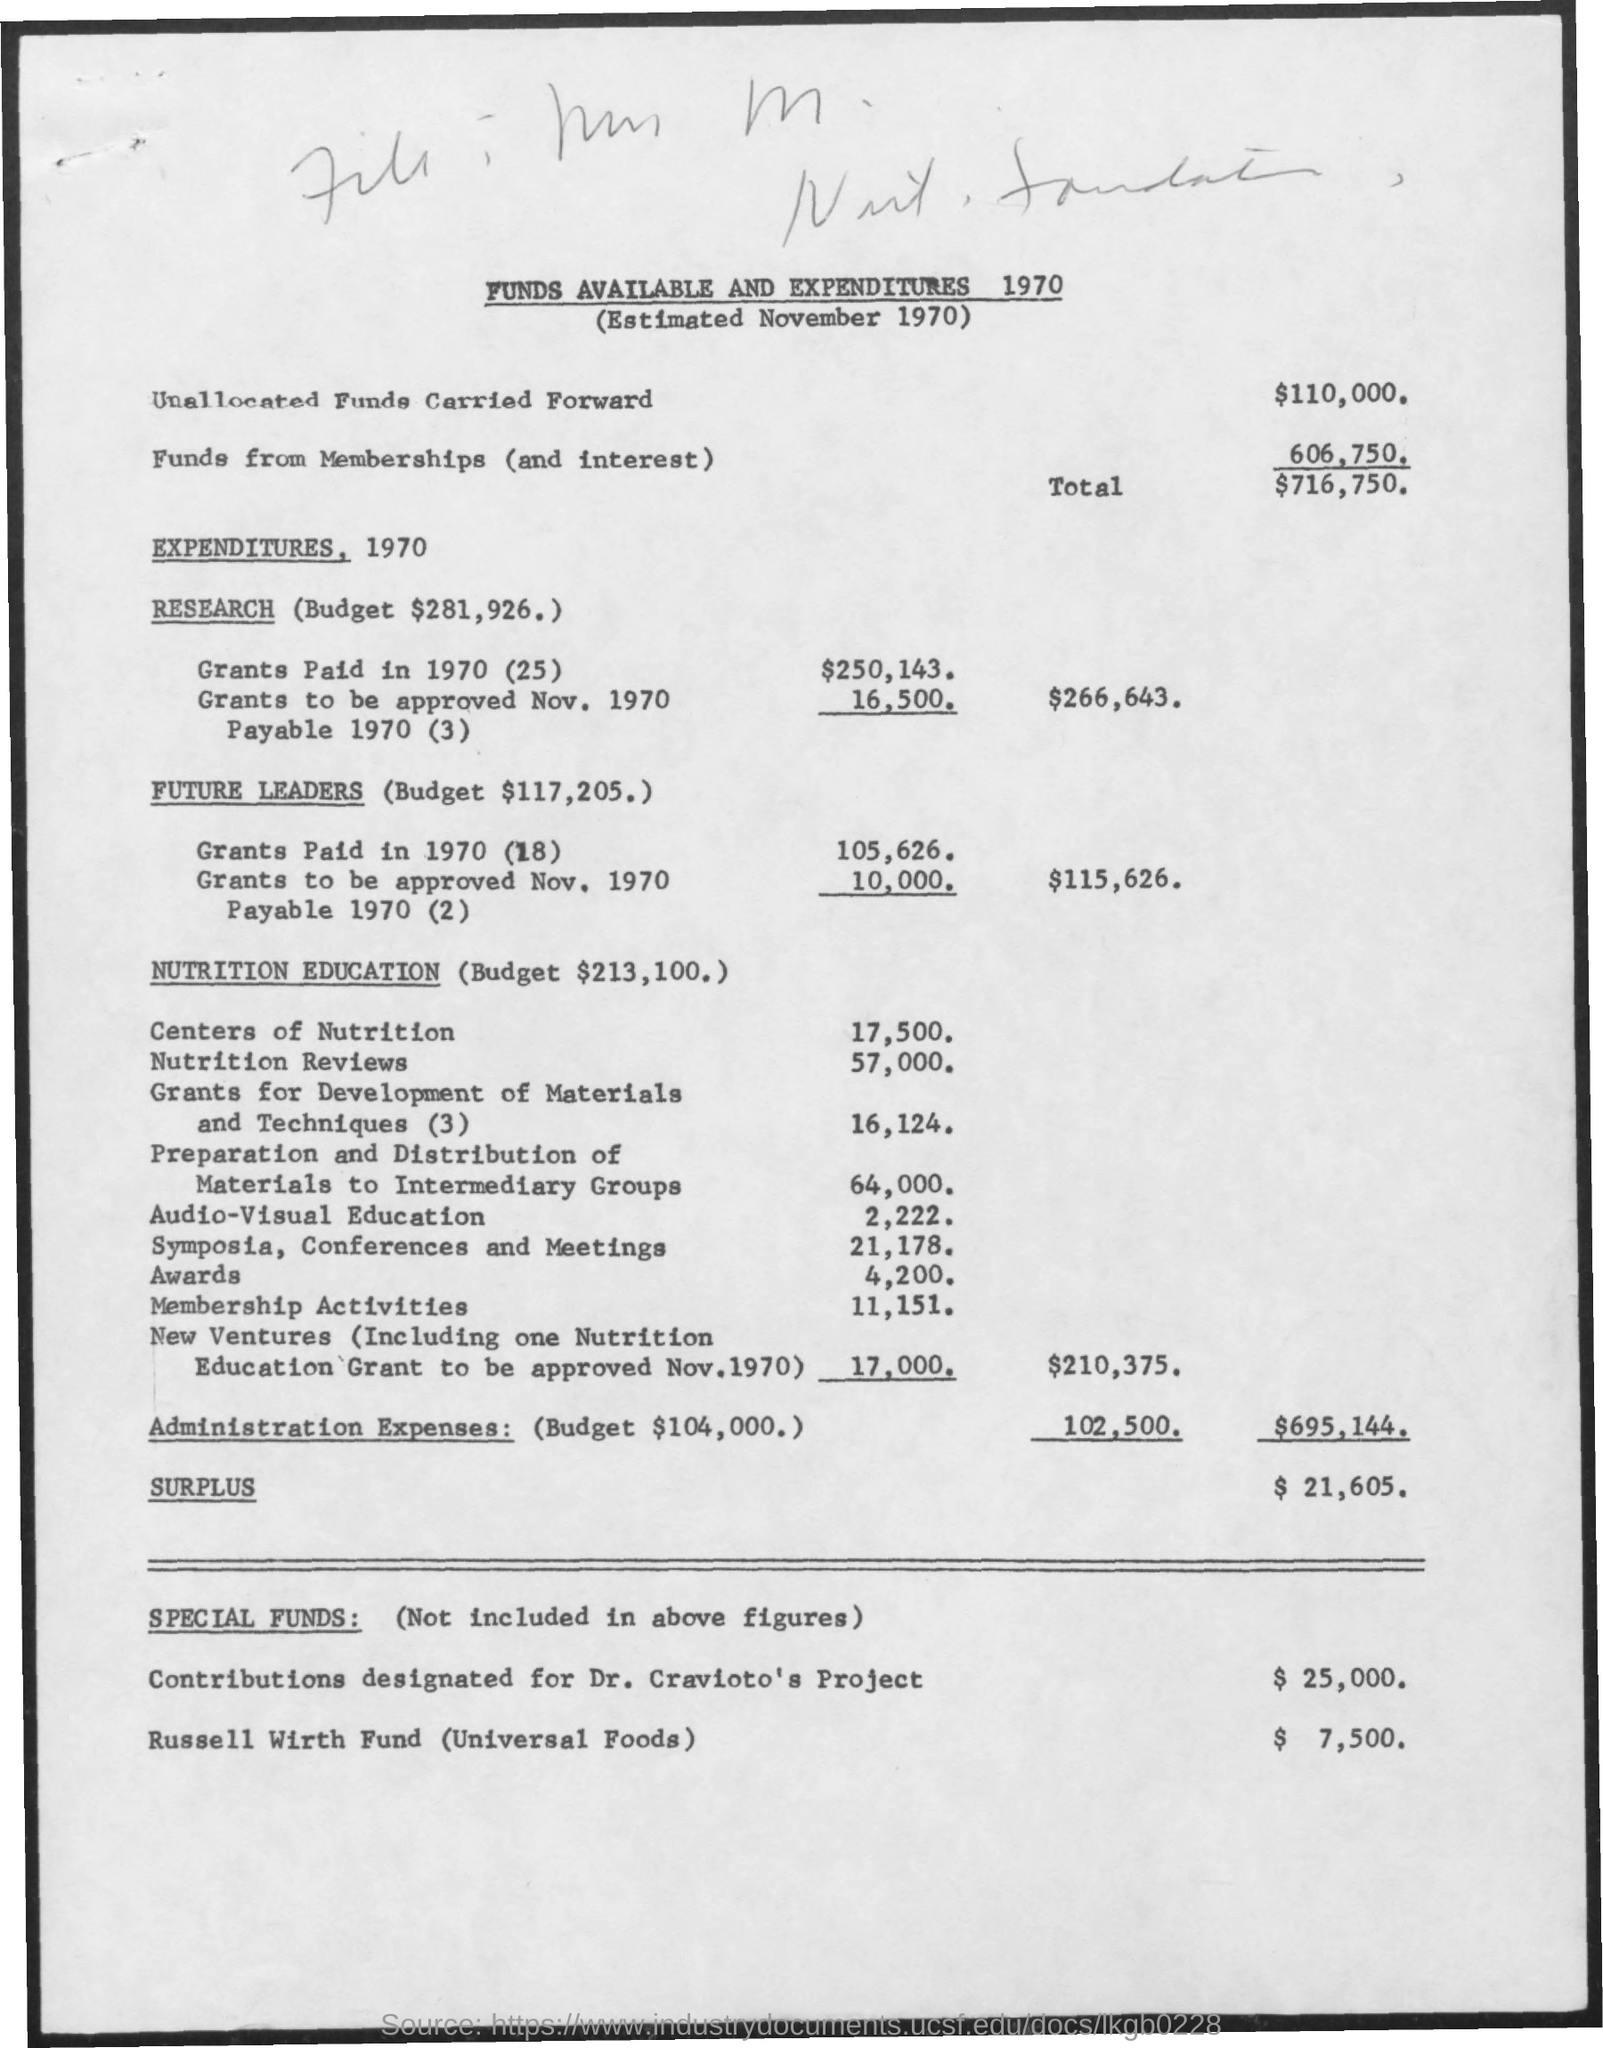What is the amount  of unallocated funds carried forward mentioned ?
Offer a terse response. $ 110,000. What is the amount of funds from memberships(and interest) ?
Provide a succinct answer. 606,750. What is the total amount mentioned ?
Provide a short and direct response. $ 716,750. What is the budget for research mentioned ?
Provide a short and direct response. $281,926. What is the budget mentioned for future leaders ?
Offer a terse response. $117,205. What is the budget mentioned for nutrition education ?
Ensure brevity in your answer.  $213,100. What is the budget mentioned for administration expenses ?
Ensure brevity in your answer.  $104,000. What is the amount mentioned for russell wirth fund ?
Make the answer very short. $ 7,500. 